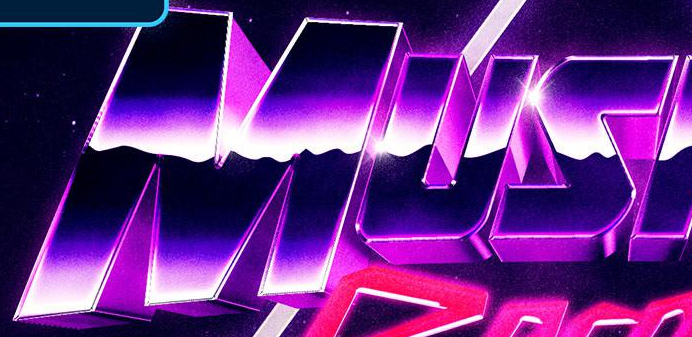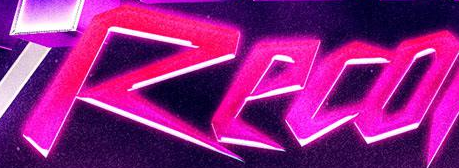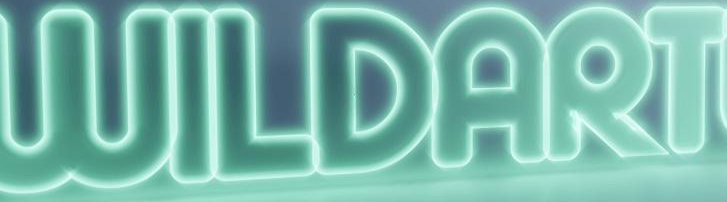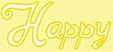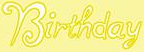What words are shown in these images in order, separated by a semicolon? MUS; Reco; WILDART; Happy; Birthday 